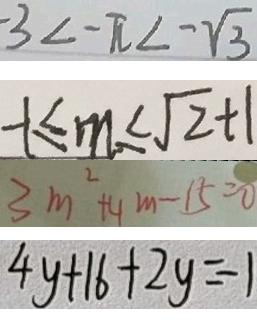Convert formula to latex. <formula><loc_0><loc_0><loc_500><loc_500>- 3 < - \pi < - \sqrt { 3 } 
 - 1 \leq m \leq \sqrt { 2 } + 1 
 3 m ^ { 2 } + 4 m - 1 5 = 0 
 4 y + 1 6 + 2 y = - 1</formula> 